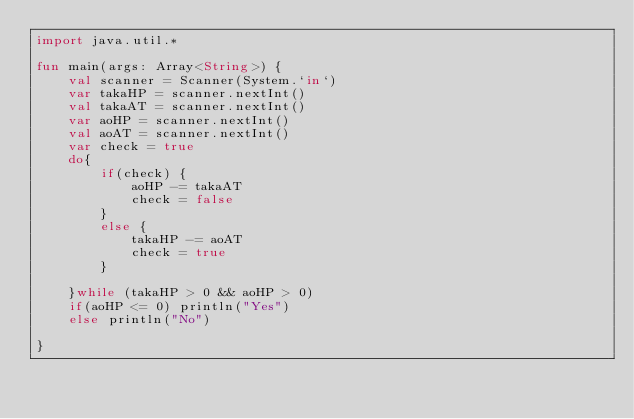<code> <loc_0><loc_0><loc_500><loc_500><_Kotlin_>import java.util.*

fun main(args: Array<String>) {
    val scanner = Scanner(System.`in`)
    var takaHP = scanner.nextInt()
    val takaAT = scanner.nextInt()
    var aoHP = scanner.nextInt()
    val aoAT = scanner.nextInt()
    var check = true
    do{
        if(check) {
            aoHP -= takaAT
            check = false
        }
        else {
            takaHP -= aoAT
            check = true
        }

    }while (takaHP > 0 && aoHP > 0)
    if(aoHP <= 0) println("Yes")
    else println("No")

}</code> 